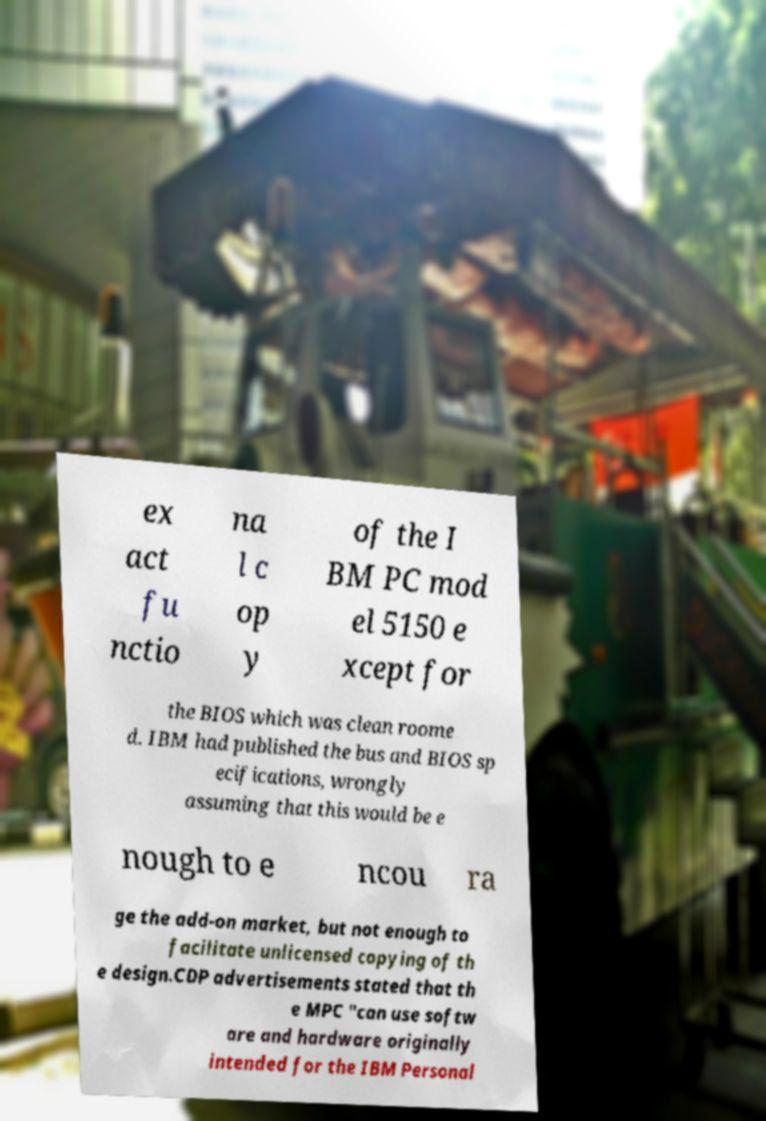Please identify and transcribe the text found in this image. ex act fu nctio na l c op y of the I BM PC mod el 5150 e xcept for the BIOS which was clean roome d. IBM had published the bus and BIOS sp ecifications, wrongly assuming that this would be e nough to e ncou ra ge the add-on market, but not enough to facilitate unlicensed copying of th e design.CDP advertisements stated that th e MPC "can use softw are and hardware originally intended for the IBM Personal 